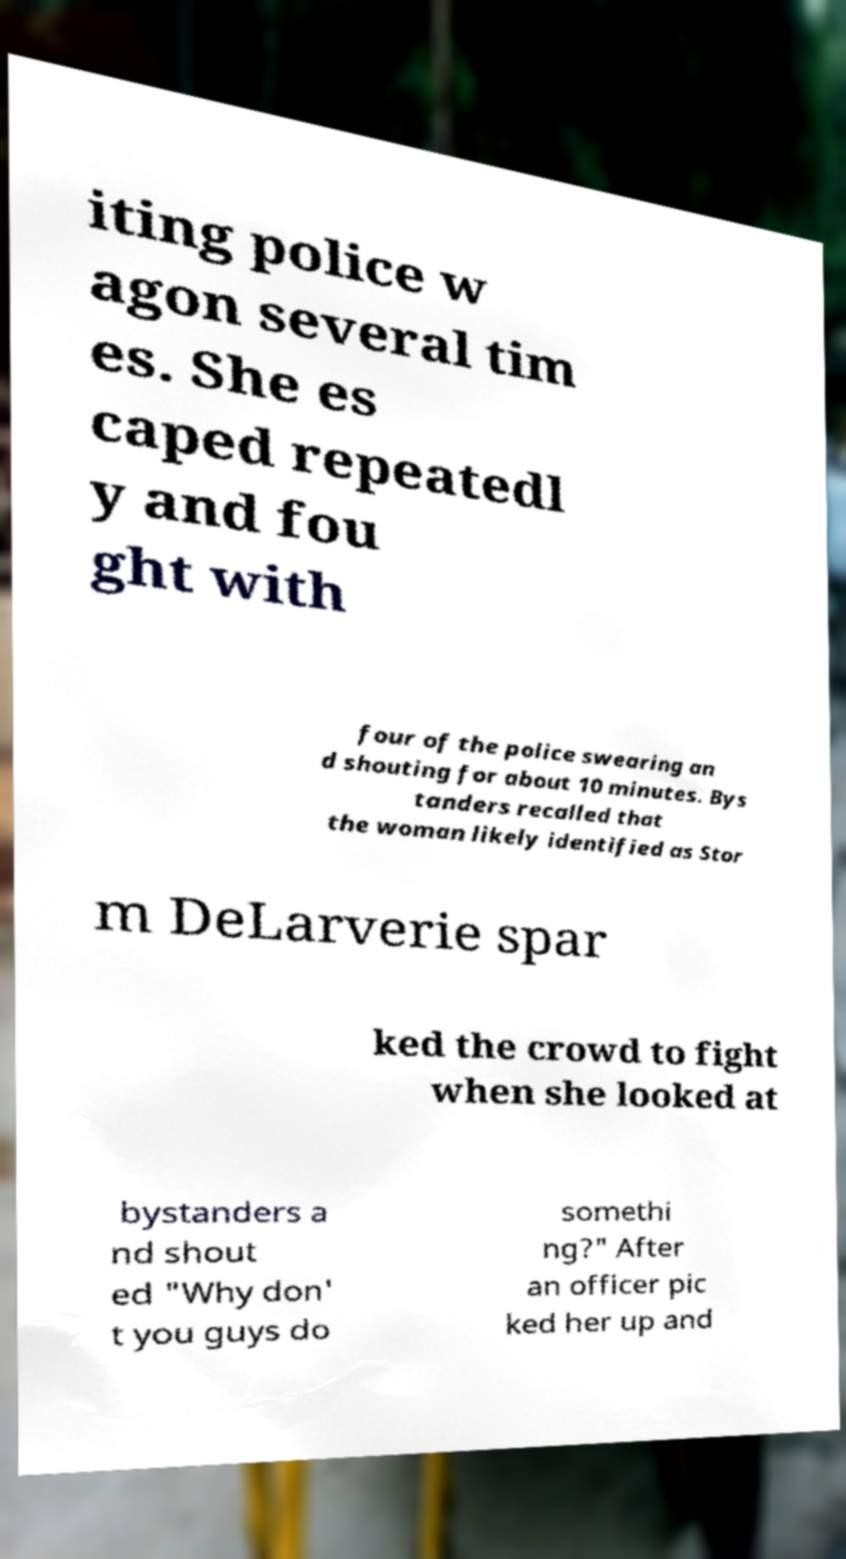What messages or text are displayed in this image? I need them in a readable, typed format. iting police w agon several tim es. She es caped repeatedl y and fou ght with four of the police swearing an d shouting for about 10 minutes. Bys tanders recalled that the woman likely identified as Stor m DeLarverie spar ked the crowd to fight when she looked at bystanders a nd shout ed "Why don' t you guys do somethi ng?" After an officer pic ked her up and 